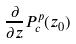<formula> <loc_0><loc_0><loc_500><loc_500>\frac { \partial } { \partial z } P _ { c } ^ { p } ( z _ { 0 } )</formula> 